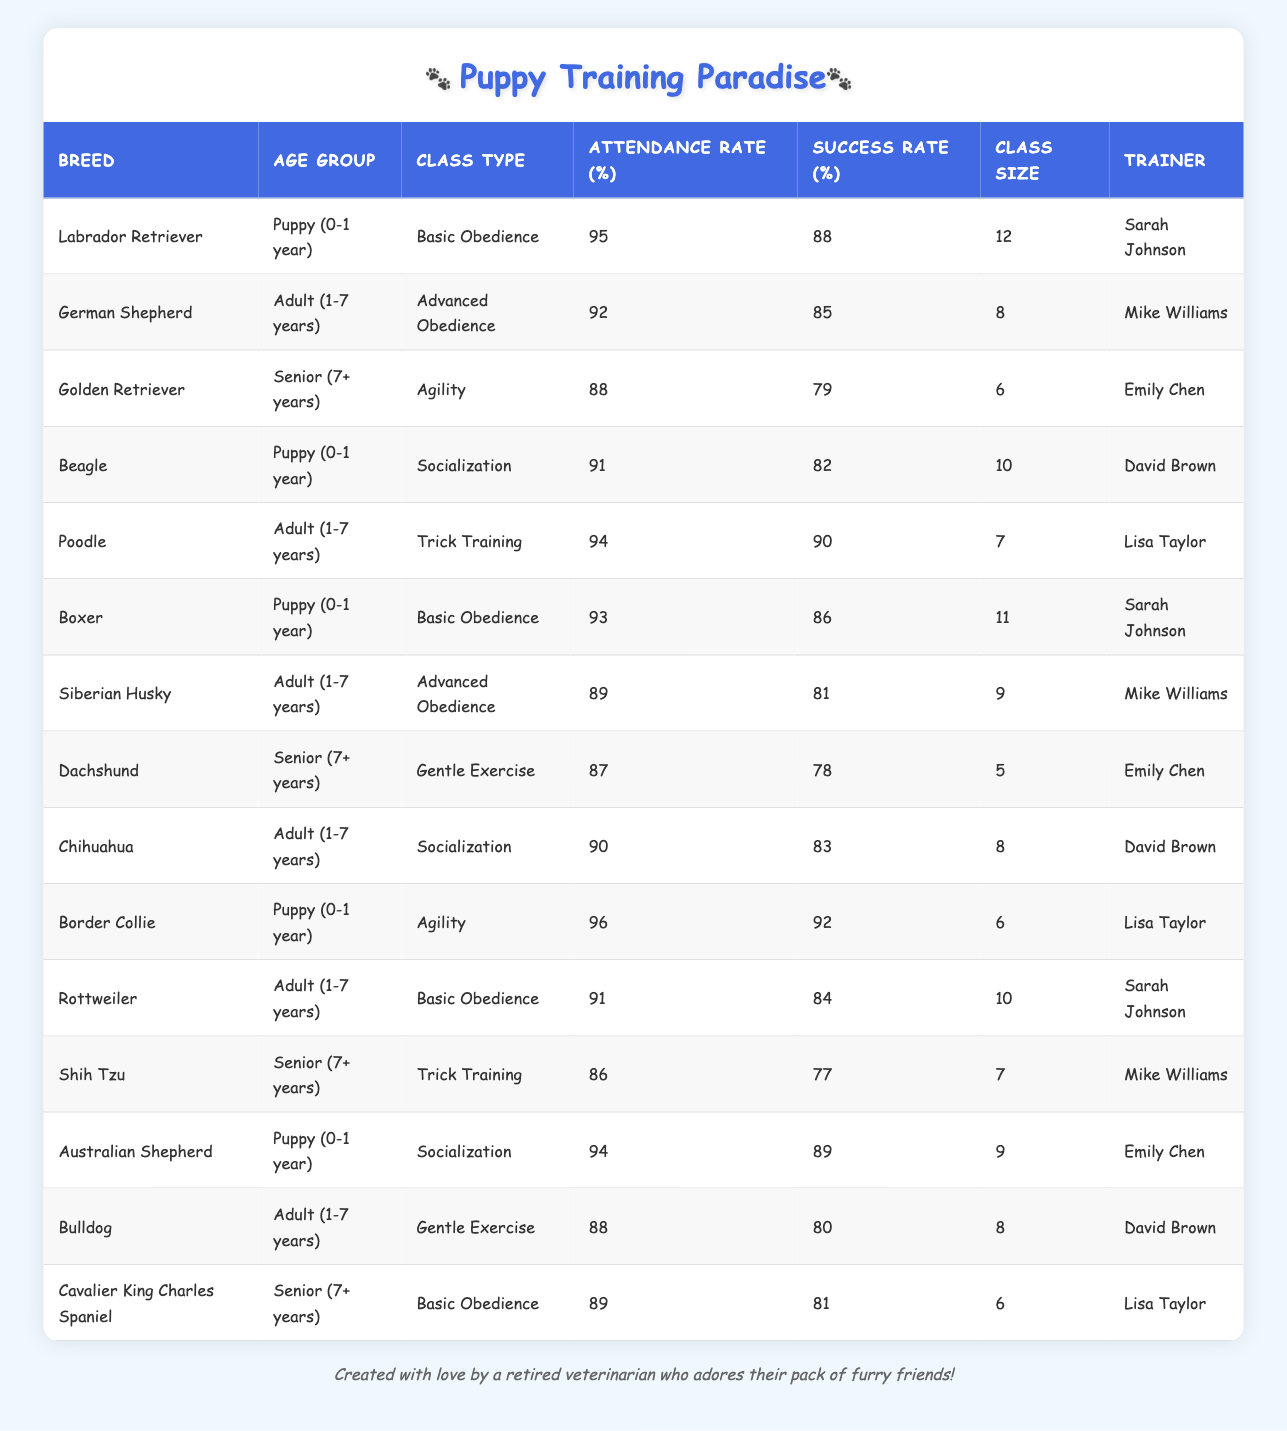What is the highest attendance rate among all breeds? The attendance rate for Labrador Retriever is 95%, and for Border Collie, it's 96%. So, the highest attendance rate is 96%.
Answer: 96 Which breed has the lowest success rate in their training class? Golden Retriever has the lowest success rate at 79% among the listed success rates.
Answer: 79 What is the average success rate for puppy classes? The success rates for puppy classes are 88, 82, 86, 92, and 89. Summing these gives 88 + 82 + 86 + 92 + 89 = 437. The average is 437/5 = 87.4.
Answer: 87.4 Is the attendance rate for Sih Tzu higher than 85%? The attendance rate for Shih Tzu is 86%, which is indeed higher than 85%.
Answer: Yes How many dogs attended the agility class for puppies? The only puppies that attended agility classes are the Border Collie (6) and Labrador Retriever (12). Adding these together gives 6 + 12 = 18 dogs.
Answer: 18 Which trainer handled the most number of dogs in puppy classes, and how many were there? Sarah Johnson trained Labradors (12), and Boxer (11), totaling 23 puppies. Meanwhile, Emily Chen trained Australian Shepherds (9) and Border Collies (6), totaling 15. So, Sarah Johnson had the most with 23 poodles.
Answer: 23 What breed in the senior category had the highest attendance rate, and what was the rate? Both Cavalier King Charles Spaniel and Golden Retriever had attendance rates of 89% and 88%, respectively. Hence, the senior category's highest attendance rate is 89% for Cavalier King Charles Spaniel.
Answer: 89 Is a German Shepherd's attendance rate higher than that of a Beagle's? German Shepherd has a 92% attendance rate while Beagle has 91%, which means German Shepherd's attendance is higher.
Answer: Yes What was the class type with the highest average attendance rate? The classes with the highest attendance rates—Puppy classes (average 92.2) and Adult classes (average 90.8)—show that puppy classes held this distinction.
Answer: Puppy classes 